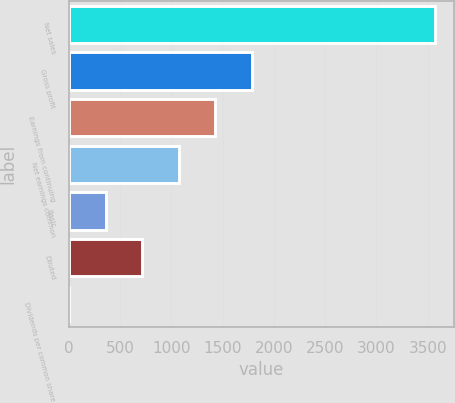Convert chart. <chart><loc_0><loc_0><loc_500><loc_500><bar_chart><fcel>Net sales<fcel>Gross profit<fcel>Earnings from continuing<fcel>Net earnings common<fcel>Basic<fcel>Diluted<fcel>Dividends per common share<nl><fcel>3574<fcel>1787.23<fcel>1429.88<fcel>1072.53<fcel>357.83<fcel>715.18<fcel>0.48<nl></chart> 